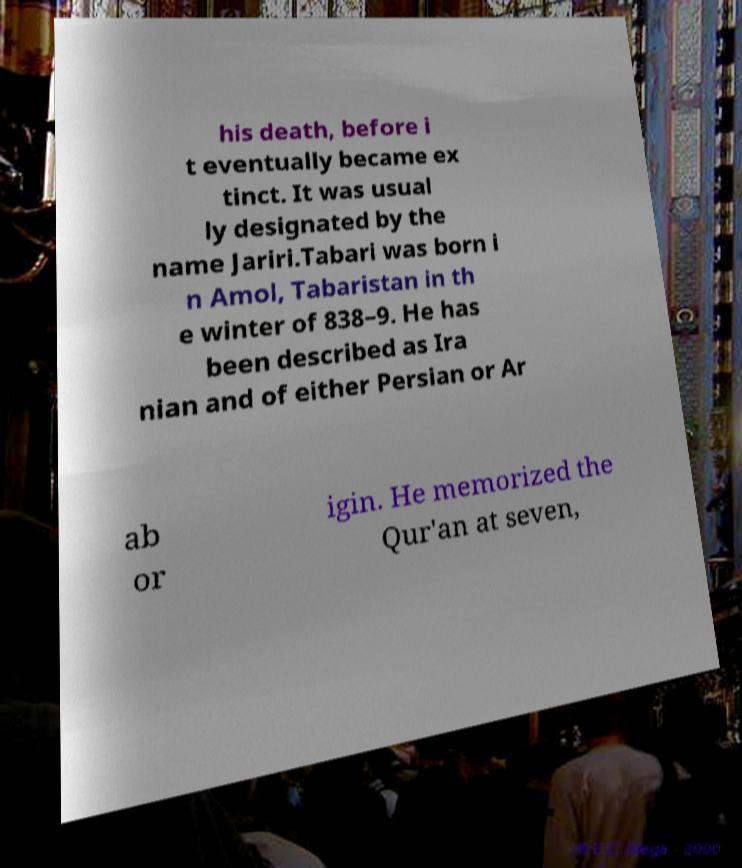Please read and relay the text visible in this image. What does it say? his death, before i t eventually became ex tinct. It was usual ly designated by the name Jariri.Tabari was born i n Amol, Tabaristan in th e winter of 838–9. He has been described as Ira nian and of either Persian or Ar ab or igin. He memorized the Qur'an at seven, 